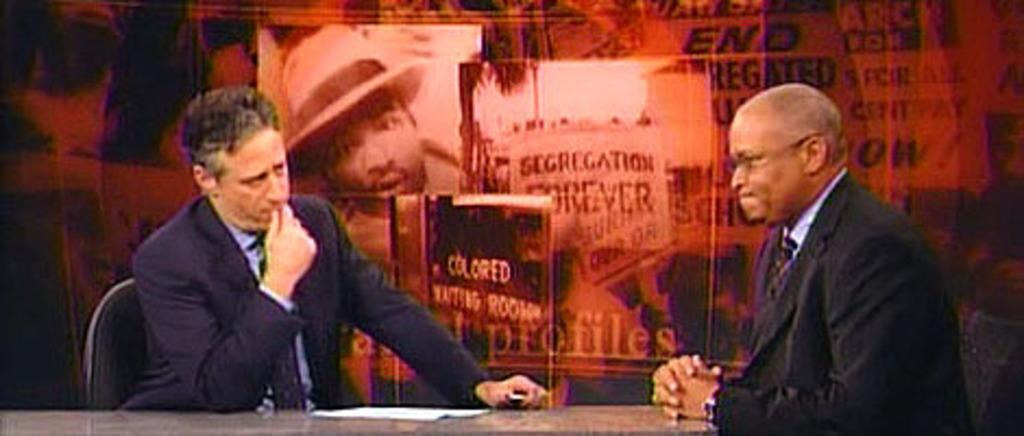How many people are in the image? There are two men in the image. What are the men doing in the image? The men are sitting on chairs. What is located at the bottom of the image? There is an object at the bottom of the image. What is placed on top of the object? There is a paper on top of the object. What can be seen in the background of the image? There is a banner in the background of the image. What type of plastic material is used to make the chairs in the image? There is no information about the material used to make the chairs in the image. In which direction are the men facing in the image? The image does not provide information about the direction the men are facing. 